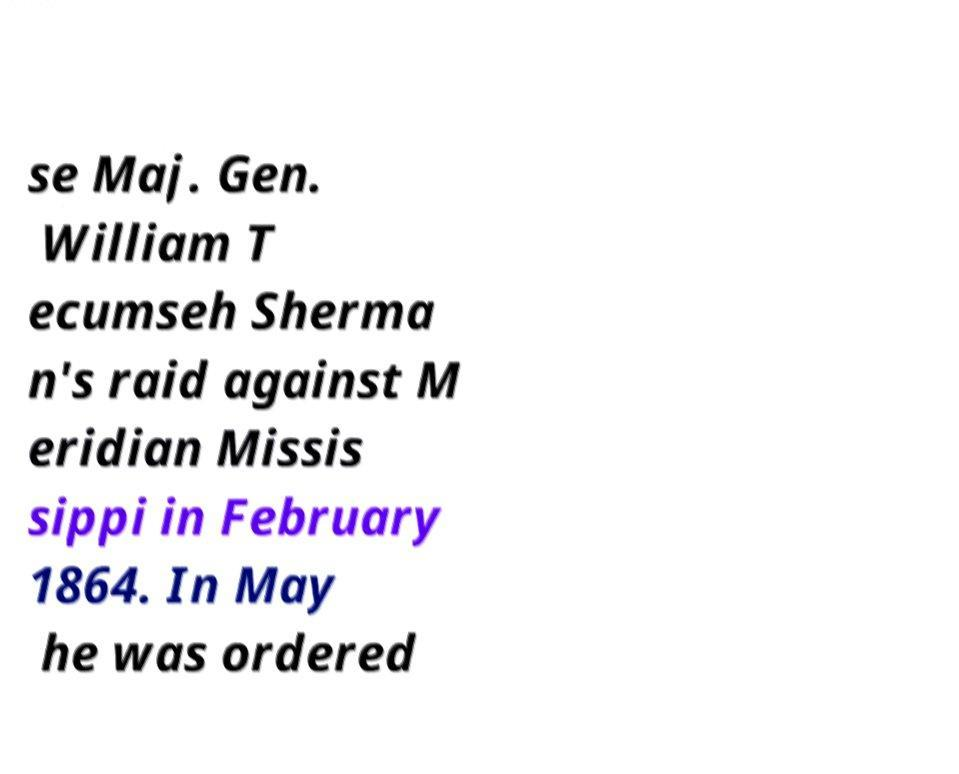Please identify and transcribe the text found in this image. se Maj. Gen. William T ecumseh Sherma n's raid against M eridian Missis sippi in February 1864. In May he was ordered 